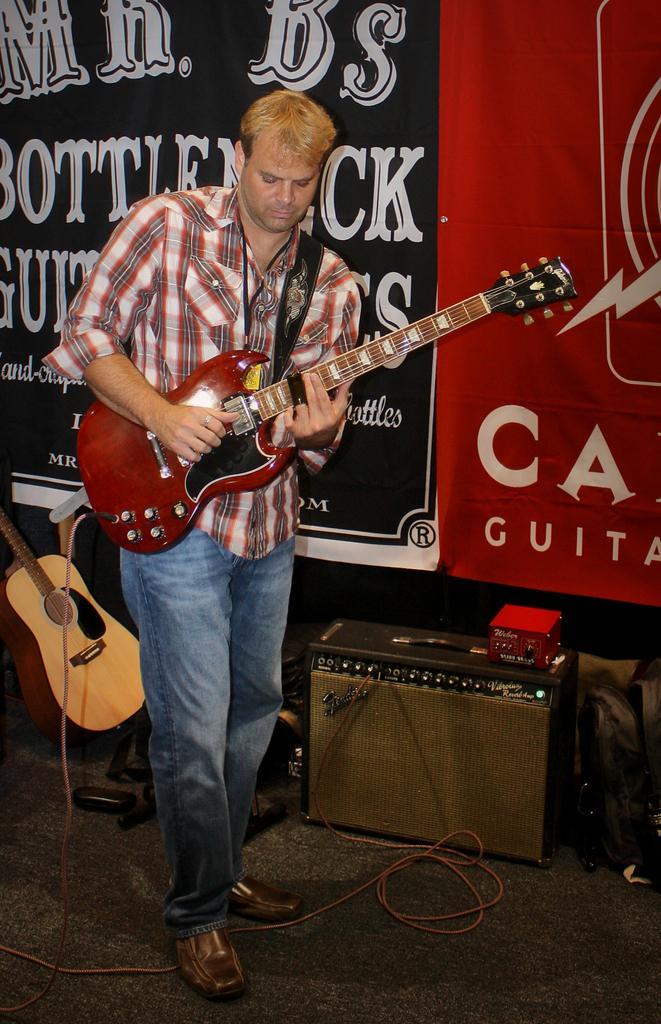In one or two sentences, can you explain what this image depicts? This is the man standing and playing guitar. This looks like a speaker. I can see red object placed here. This is another guitar. These are the banners with letters on it. 